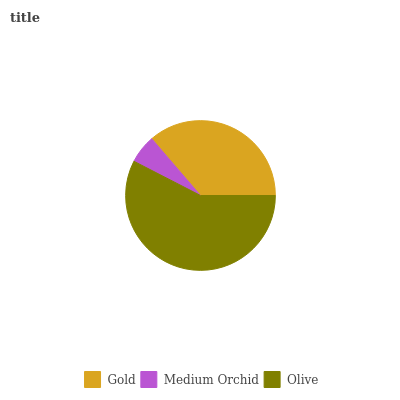Is Medium Orchid the minimum?
Answer yes or no. Yes. Is Olive the maximum?
Answer yes or no. Yes. Is Olive the minimum?
Answer yes or no. No. Is Medium Orchid the maximum?
Answer yes or no. No. Is Olive greater than Medium Orchid?
Answer yes or no. Yes. Is Medium Orchid less than Olive?
Answer yes or no. Yes. Is Medium Orchid greater than Olive?
Answer yes or no. No. Is Olive less than Medium Orchid?
Answer yes or no. No. Is Gold the high median?
Answer yes or no. Yes. Is Gold the low median?
Answer yes or no. Yes. Is Medium Orchid the high median?
Answer yes or no. No. Is Medium Orchid the low median?
Answer yes or no. No. 